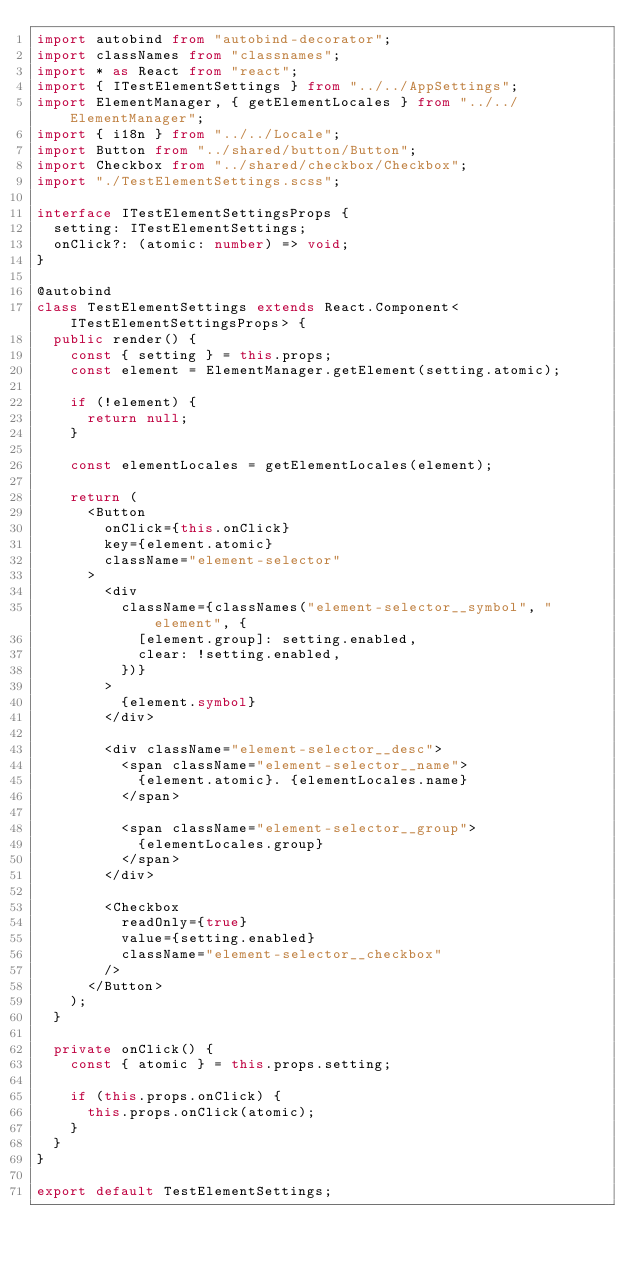Convert code to text. <code><loc_0><loc_0><loc_500><loc_500><_TypeScript_>import autobind from "autobind-decorator";
import classNames from "classnames";
import * as React from "react";
import { ITestElementSettings } from "../../AppSettings";
import ElementManager, { getElementLocales } from "../../ElementManager";
import { i18n } from "../../Locale";
import Button from "../shared/button/Button";
import Checkbox from "../shared/checkbox/Checkbox";
import "./TestElementSettings.scss";

interface ITestElementSettingsProps {
  setting: ITestElementSettings;
  onClick?: (atomic: number) => void;
}

@autobind
class TestElementSettings extends React.Component<ITestElementSettingsProps> {
  public render() {
    const { setting } = this.props;
    const element = ElementManager.getElement(setting.atomic);

    if (!element) {
      return null;
    }

    const elementLocales = getElementLocales(element);

    return (
      <Button
        onClick={this.onClick}
        key={element.atomic}
        className="element-selector"
      >
        <div
          className={classNames("element-selector__symbol", "element", {
            [element.group]: setting.enabled,
            clear: !setting.enabled,
          })}
        >
          {element.symbol}
        </div>

        <div className="element-selector__desc">
          <span className="element-selector__name">
            {element.atomic}. {elementLocales.name}
          </span>

          <span className="element-selector__group">
            {elementLocales.group}
          </span>
        </div>

        <Checkbox
          readOnly={true}
          value={setting.enabled}
          className="element-selector__checkbox"
        />
      </Button>
    );
  }

  private onClick() {
    const { atomic } = this.props.setting;

    if (this.props.onClick) {
      this.props.onClick(atomic);
    }
  }
}

export default TestElementSettings;
</code> 